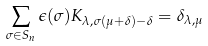<formula> <loc_0><loc_0><loc_500><loc_500>\sum _ { \sigma \in S _ { n } } \epsilon ( \sigma ) K _ { \lambda , \sigma ( \mu + \delta ) - \delta } = \delta _ { \lambda , \mu }</formula> 